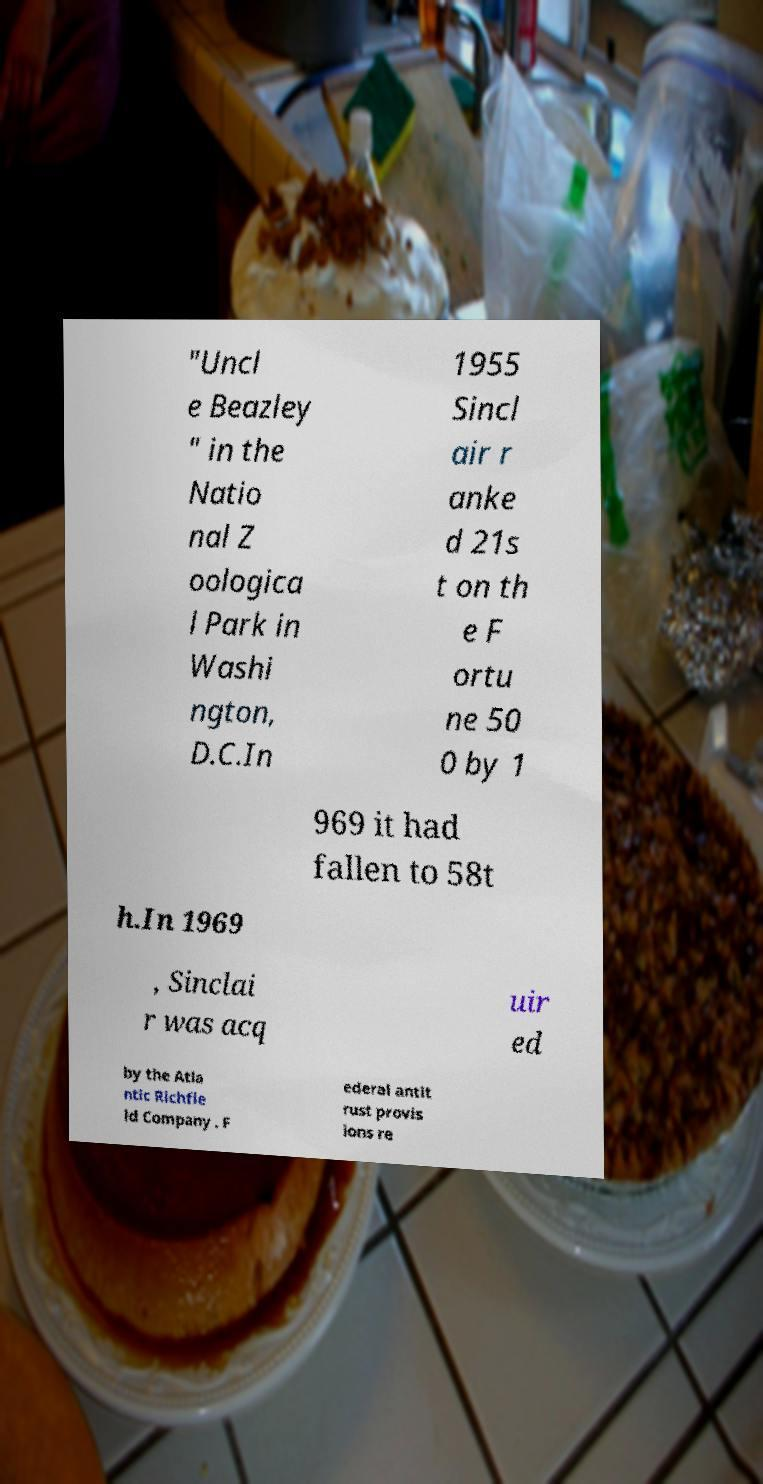What messages or text are displayed in this image? I need them in a readable, typed format. "Uncl e Beazley " in the Natio nal Z oologica l Park in Washi ngton, D.C.In 1955 Sincl air r anke d 21s t on th e F ortu ne 50 0 by 1 969 it had fallen to 58t h.In 1969 , Sinclai r was acq uir ed by the Atla ntic Richfie ld Company . F ederal antit rust provis ions re 